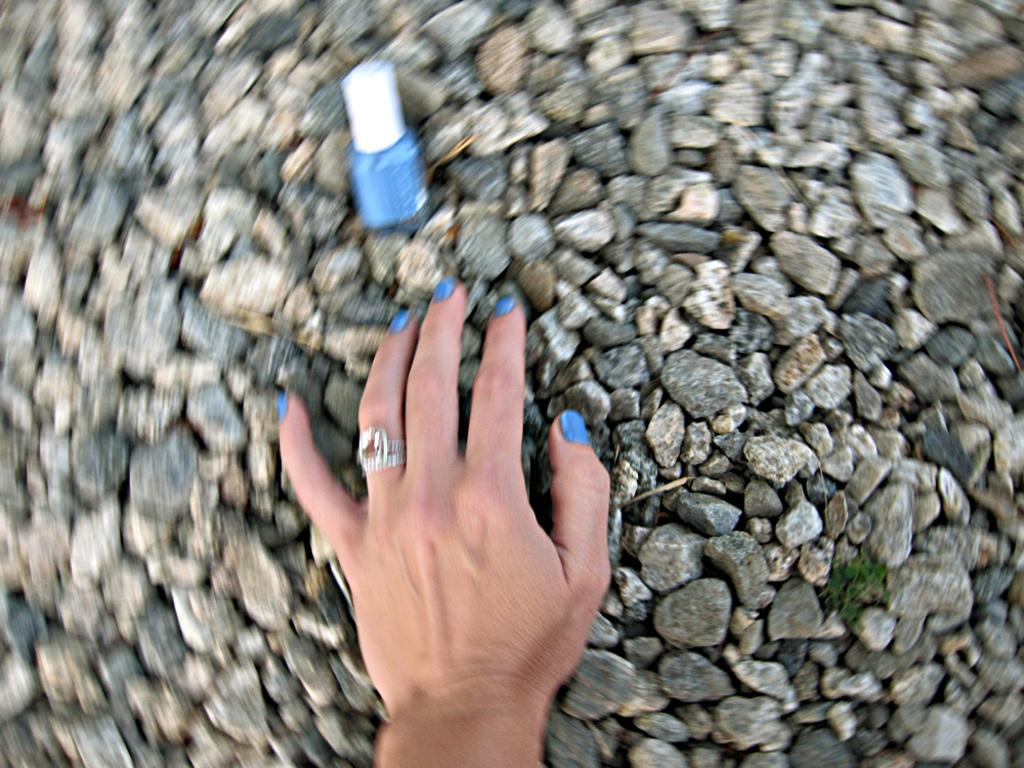What is the main subject in the center of the image? There is a hand in the center of the image. What can be seen at the bottom of the image? There are stones at the bottom of the image. What type of yard is visible in the image? There is no yard visible in the image; it only features a hand and stones. How many matches can be seen in the image? There are no matches present in the image. 